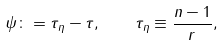<formula> <loc_0><loc_0><loc_500><loc_500>\psi \colon = \tau _ { \eta } - \tau , \quad \tau _ { \eta } \equiv \frac { n - 1 } { r } ,</formula> 